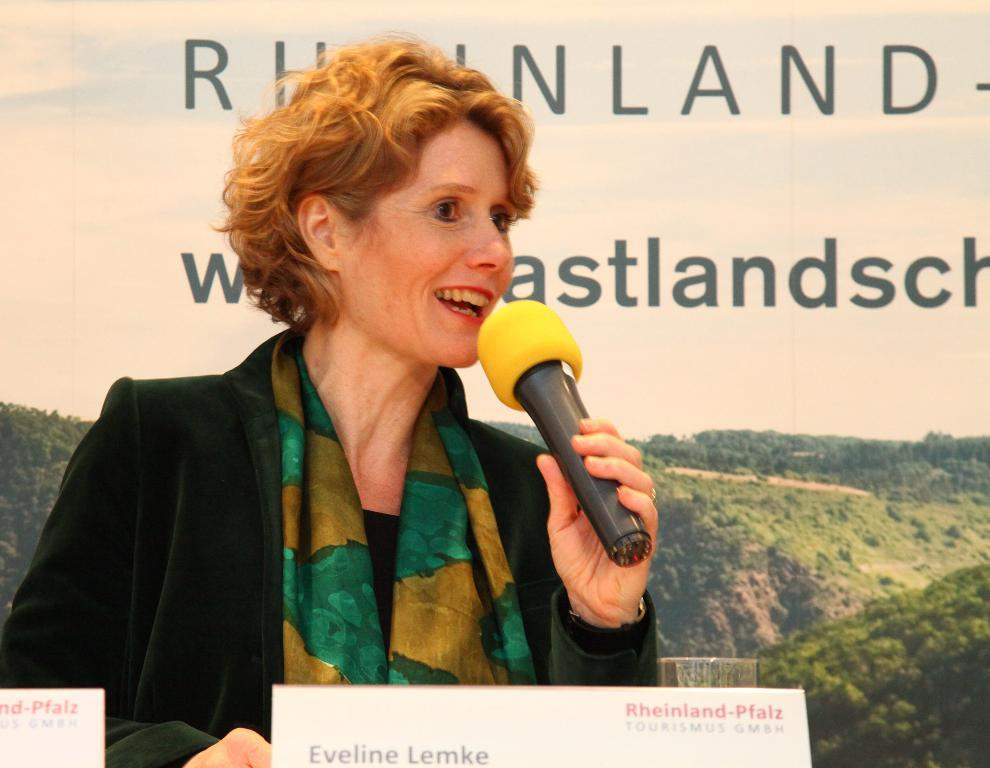Who is the main subject in the image? There is a lady in the image. What is the lady holding in the image? The lady is holding a mic. What is the lady standing in front of? The lady is standing in front of name boards. What can be seen in the background of the image? There is a banner in the background of the image. How many sheep are visible in the image? There are no sheep present in the image. What is the lady feeling ashamed about in the image? There is no indication in the image that the lady is feeling ashamed about anything. 